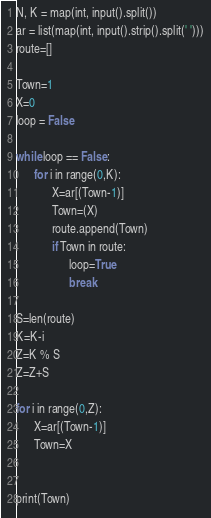<code> <loc_0><loc_0><loc_500><loc_500><_Python_>N, K = map(int, input().split())
ar = list(map(int, input().strip().split(' ')))
route=[]

Town=1
X=0
loop = False

while loop == False:
      for i in range(0,K):
            X=ar[(Town-1)]
            Town=(X)
            route.append(Town)
            if Town in route:
                  loop=True
                  break
      
S=len(route)
K=K-i
Z=K % S
Z=Z+S

for i in range(0,Z):
      X=ar[(Town-1)]
      Town=X

      
print(Town)</code> 